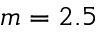<formula> <loc_0><loc_0><loc_500><loc_500>m = 2 . 5</formula> 